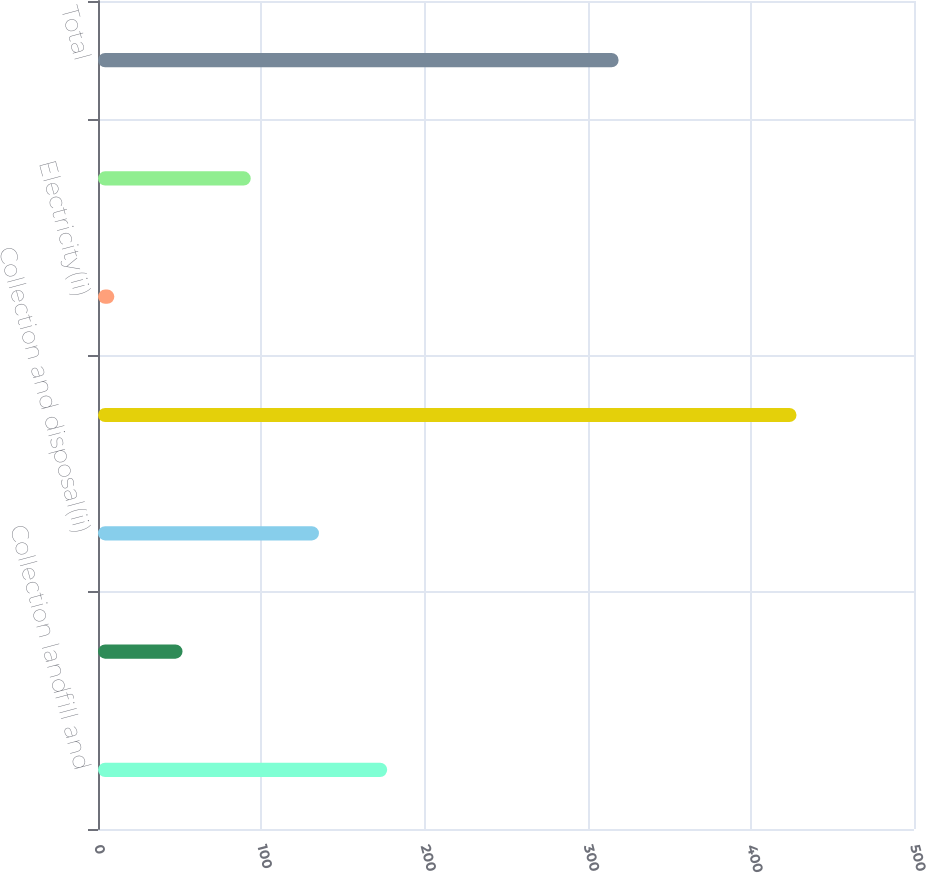<chart> <loc_0><loc_0><loc_500><loc_500><bar_chart><fcel>Collection landfill and<fcel>Waste-to-energy disposal(ii)<fcel>Collection and disposal(ii)<fcel>Recycling commodities<fcel>Electricity(ii)<fcel>Fuel surcharges and mandated<fcel>Total<nl><fcel>177.2<fcel>51.8<fcel>135.4<fcel>428<fcel>10<fcel>93.6<fcel>319<nl></chart> 